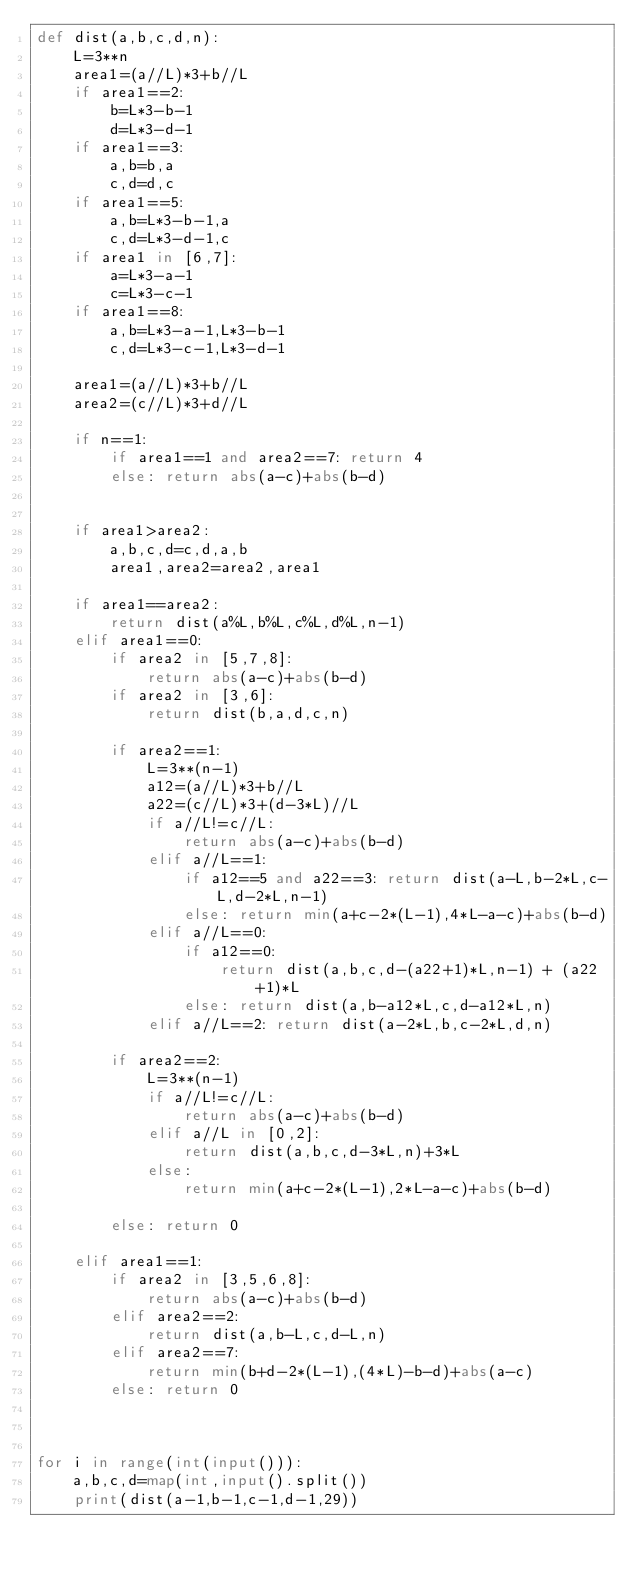<code> <loc_0><loc_0><loc_500><loc_500><_Python_>def dist(a,b,c,d,n):
    L=3**n
    area1=(a//L)*3+b//L
    if area1==2:
        b=L*3-b-1
        d=L*3-d-1
    if area1==3:
        a,b=b,a
        c,d=d,c
    if area1==5:
        a,b=L*3-b-1,a
        c,d=L*3-d-1,c
    if area1 in [6,7]:
        a=L*3-a-1
        c=L*3-c-1
    if area1==8:
        a,b=L*3-a-1,L*3-b-1
        c,d=L*3-c-1,L*3-d-1

    area1=(a//L)*3+b//L
    area2=(c//L)*3+d//L
    
    if n==1:
        if area1==1 and area2==7: return 4
        else: return abs(a-c)+abs(b-d)


    if area1>area2:
        a,b,c,d=c,d,a,b
        area1,area2=area2,area1

    if area1==area2:
        return dist(a%L,b%L,c%L,d%L,n-1)
    elif area1==0:
        if area2 in [5,7,8]:
            return abs(a-c)+abs(b-d)
        if area2 in [3,6]:
            return dist(b,a,d,c,n)

        if area2==1:
            L=3**(n-1)
            a12=(a//L)*3+b//L
            a22=(c//L)*3+(d-3*L)//L
            if a//L!=c//L:
                return abs(a-c)+abs(b-d)
            elif a//L==1:
                if a12==5 and a22==3: return dist(a-L,b-2*L,c-L,d-2*L,n-1)
                else: return min(a+c-2*(L-1),4*L-a-c)+abs(b-d)
            elif a//L==0:
                if a12==0:
                    return dist(a,b,c,d-(a22+1)*L,n-1) + (a22+1)*L
                else: return dist(a,b-a12*L,c,d-a12*L,n) 
            elif a//L==2: return dist(a-2*L,b,c-2*L,d,n)

        if area2==2:
            L=3**(n-1)
            if a//L!=c//L:
                return abs(a-c)+abs(b-d)
            elif a//L in [0,2]:
                return dist(a,b,c,d-3*L,n)+3*L
            else:
                return min(a+c-2*(L-1),2*L-a-c)+abs(b-d)

        else: return 0

    elif area1==1:
        if area2 in [3,5,6,8]:
            return abs(a-c)+abs(b-d)
        elif area2==2:
            return dist(a,b-L,c,d-L,n)
        elif area2==7:
            return min(b+d-2*(L-1),(4*L)-b-d)+abs(a-c)
        else: return 0



for i in range(int(input())):
    a,b,c,d=map(int,input().split())
    print(dist(a-1,b-1,c-1,d-1,29))</code> 